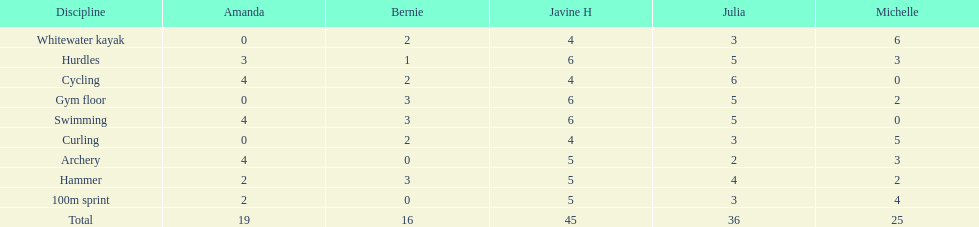In the hurdles, what was bernie's point tally? 1. 